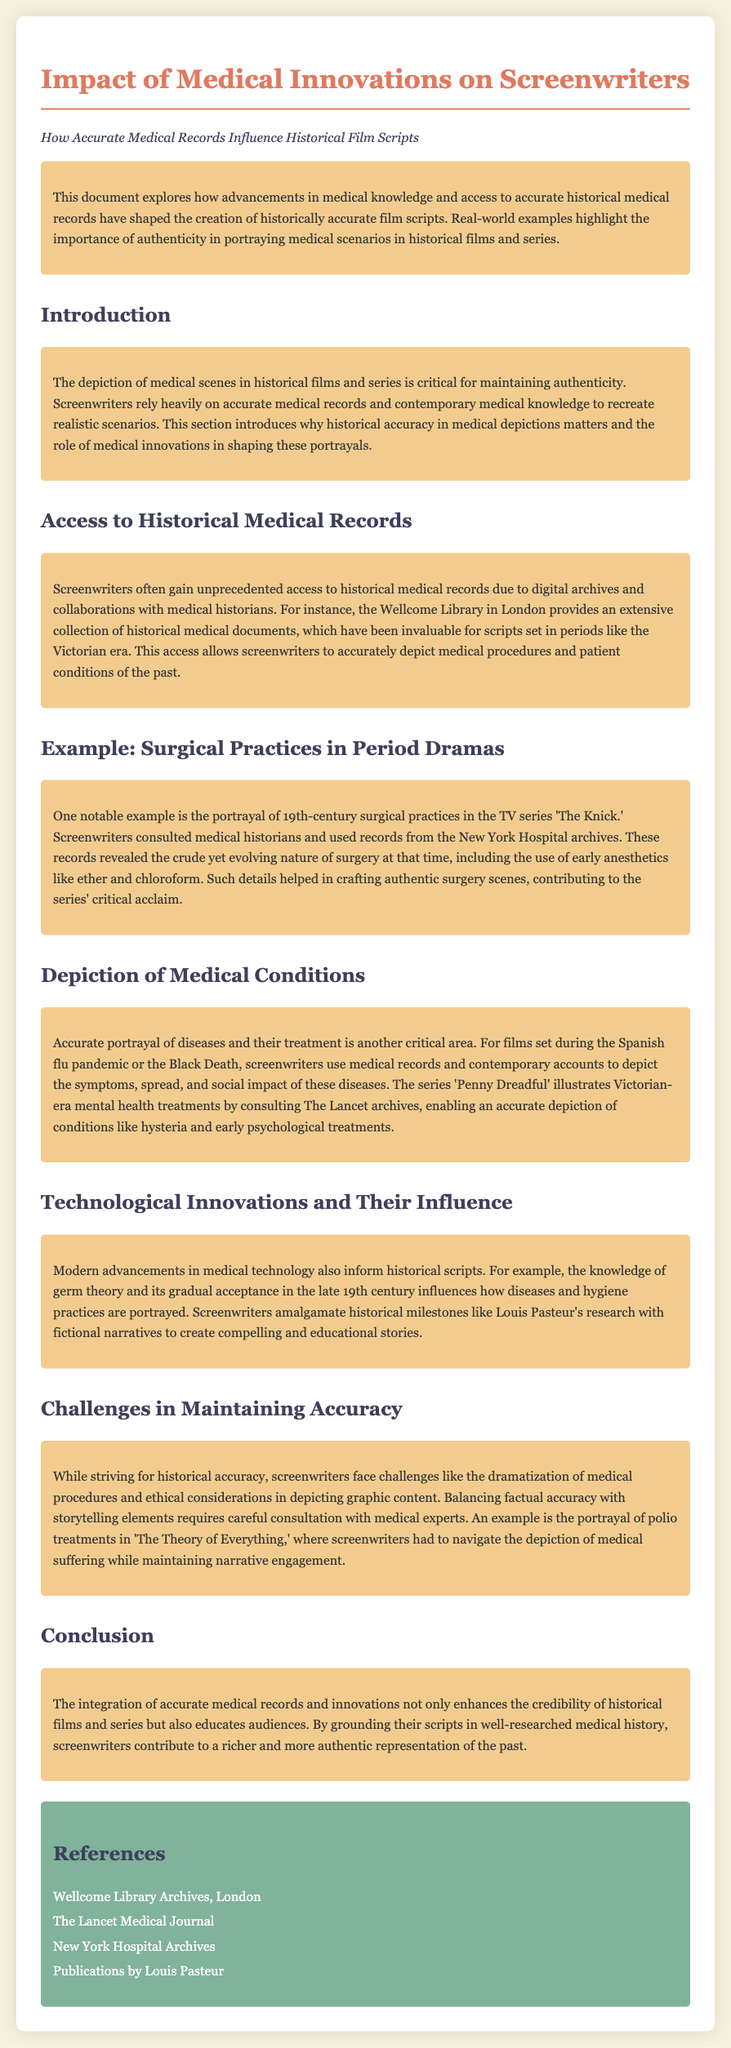What institution provides access to historical medical records? The document mentions the Wellcome Library in London as a provider of historical medical records.
Answer: Wellcome Library Which TV series consulted medical historians for 19th-century surgical practices? The document states that 'The Knick' consulted medical historians for accurate surgical practices.
Answer: The Knick What medical conditions were illustrated in 'Penny Dreadful'? The document highlights conditions like hysteria and early psychological treatments depicted in 'Penny Dreadful'.
Answer: Hysteria In what era does the access to historical medical records help screenwriters depict medical procedures? The document mentions the Victorian era as one period where historical medical records have been important.
Answer: Victorian era What challenge do screenwriters face in portraying medical procedures? The document notes dramatization of medical procedures as a challenge for maintaining accuracy.
Answer: Dramatization What influences how hygiene practices are portrayed in historical scripts? The document refers to the knowledge of germ theory and its acceptance affecting hygiene portrayals.
Answer: Germ theory What type of medical documents has been invaluable for scripts set in historical contexts? The document indicates that accurate historical medical records are invaluable for scripts.
Answer: Historical medical records Which archives were consulted for accurate medical accounts during the Spanish flu pandemic? The document does not specify a single archive but mentions medical records and contemporary accounts being used.
Answer: Medical records and contemporary accounts 